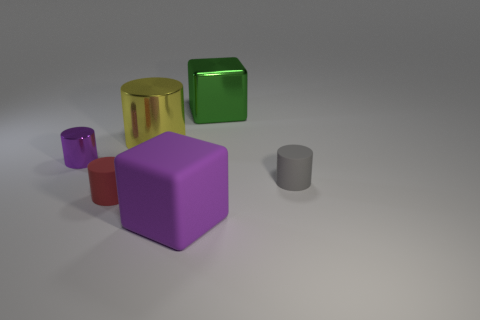Subtract all large yellow cylinders. How many cylinders are left? 3 Add 2 red cylinders. How many objects exist? 8 Subtract all purple cubes. How many cubes are left? 1 Subtract all blocks. How many objects are left? 4 Subtract all blue cubes. How many brown cylinders are left? 0 Add 1 tiny red rubber objects. How many tiny red rubber objects exist? 2 Subtract 0 red balls. How many objects are left? 6 Subtract 2 blocks. How many blocks are left? 0 Subtract all brown cubes. Subtract all yellow cylinders. How many cubes are left? 2 Subtract all tiny yellow metallic things. Subtract all tiny metallic things. How many objects are left? 5 